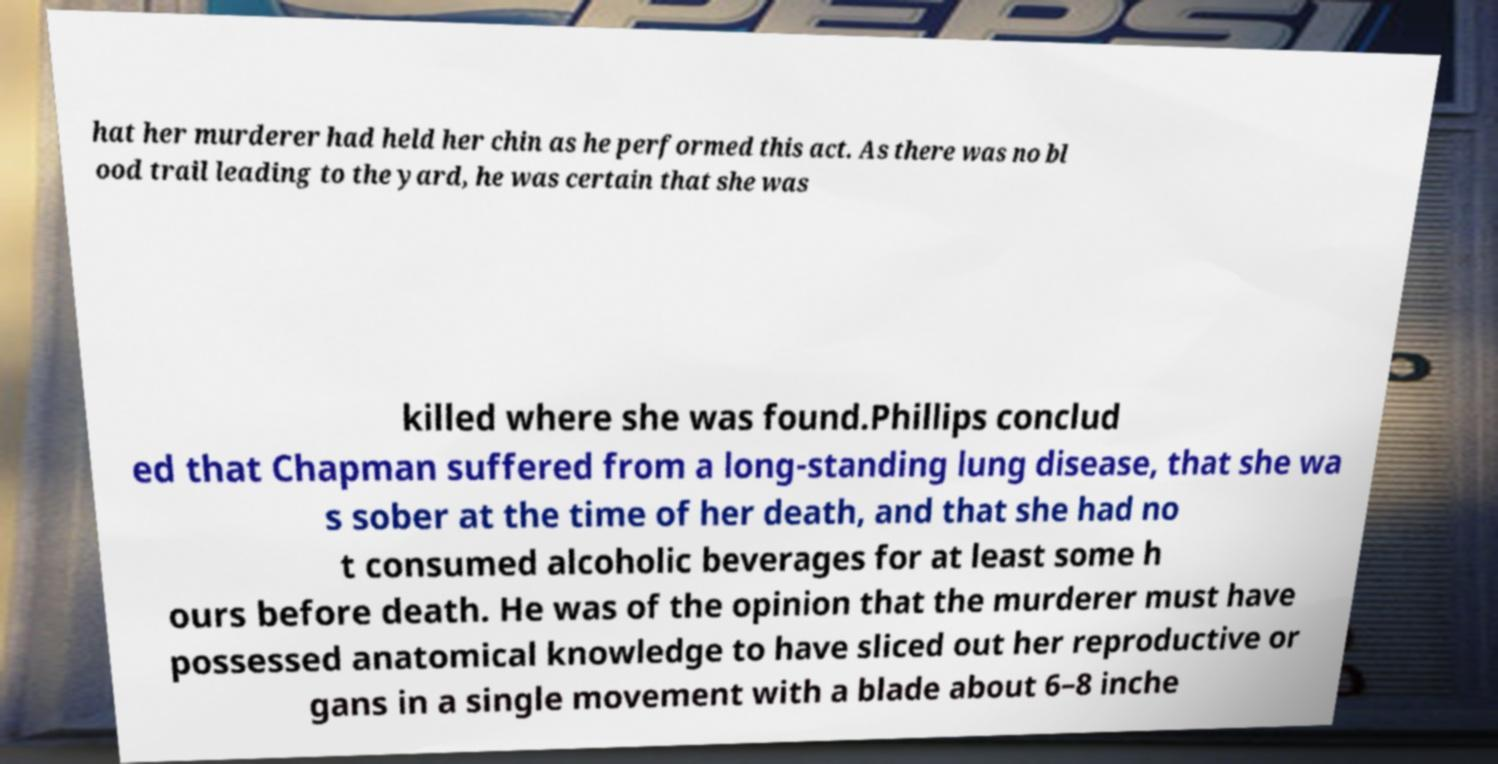I need the written content from this picture converted into text. Can you do that? hat her murderer had held her chin as he performed this act. As there was no bl ood trail leading to the yard, he was certain that she was killed where she was found.Phillips conclud ed that Chapman suffered from a long-standing lung disease, that she wa s sober at the time of her death, and that she had no t consumed alcoholic beverages for at least some h ours before death. He was of the opinion that the murderer must have possessed anatomical knowledge to have sliced out her reproductive or gans in a single movement with a blade about 6–8 inche 